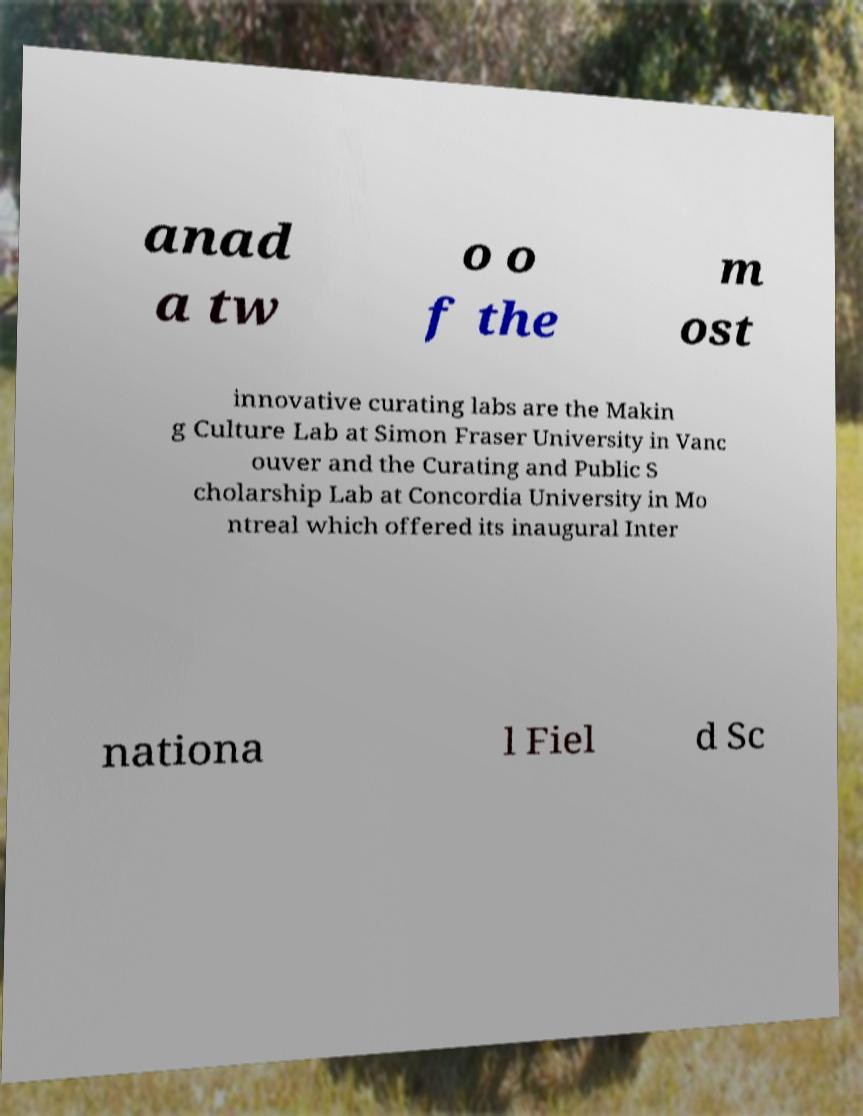Please identify and transcribe the text found in this image. anad a tw o o f the m ost innovative curating labs are the Makin g Culture Lab at Simon Fraser University in Vanc ouver and the Curating and Public S cholarship Lab at Concordia University in Mo ntreal which offered its inaugural Inter nationa l Fiel d Sc 